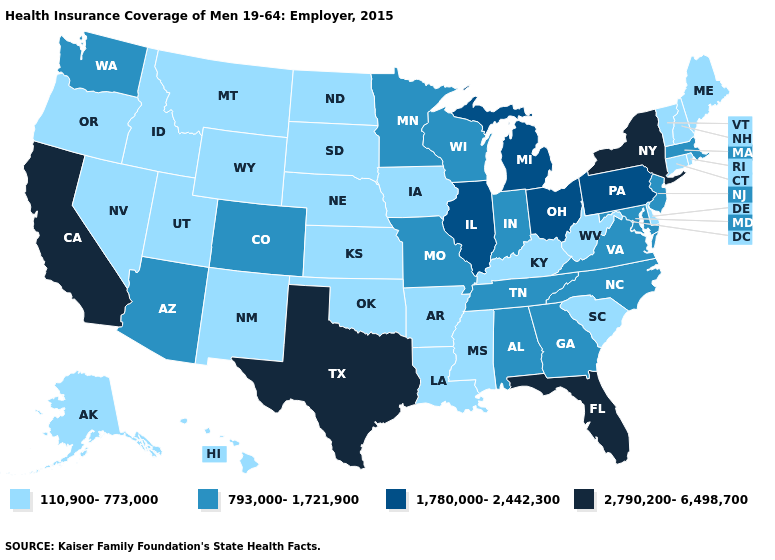Is the legend a continuous bar?
Quick response, please. No. Does Rhode Island have a lower value than Massachusetts?
Short answer required. Yes. Name the states that have a value in the range 110,900-773,000?
Quick response, please. Alaska, Arkansas, Connecticut, Delaware, Hawaii, Idaho, Iowa, Kansas, Kentucky, Louisiana, Maine, Mississippi, Montana, Nebraska, Nevada, New Hampshire, New Mexico, North Dakota, Oklahoma, Oregon, Rhode Island, South Carolina, South Dakota, Utah, Vermont, West Virginia, Wyoming. Name the states that have a value in the range 1,780,000-2,442,300?
Concise answer only. Illinois, Michigan, Ohio, Pennsylvania. Does North Dakota have a lower value than Hawaii?
Write a very short answer. No. Name the states that have a value in the range 110,900-773,000?
Keep it brief. Alaska, Arkansas, Connecticut, Delaware, Hawaii, Idaho, Iowa, Kansas, Kentucky, Louisiana, Maine, Mississippi, Montana, Nebraska, Nevada, New Hampshire, New Mexico, North Dakota, Oklahoma, Oregon, Rhode Island, South Carolina, South Dakota, Utah, Vermont, West Virginia, Wyoming. What is the highest value in the MidWest ?
Give a very brief answer. 1,780,000-2,442,300. What is the value of Iowa?
Write a very short answer. 110,900-773,000. Name the states that have a value in the range 2,790,200-6,498,700?
Give a very brief answer. California, Florida, New York, Texas. What is the value of Alaska?
Give a very brief answer. 110,900-773,000. What is the highest value in states that border Kentucky?
Write a very short answer. 1,780,000-2,442,300. Does the first symbol in the legend represent the smallest category?
Be succinct. Yes. Among the states that border New Jersey , does Delaware have the highest value?
Write a very short answer. No. Does Maryland have a lower value than Delaware?
Quick response, please. No. Among the states that border New Jersey , which have the highest value?
Keep it brief. New York. 